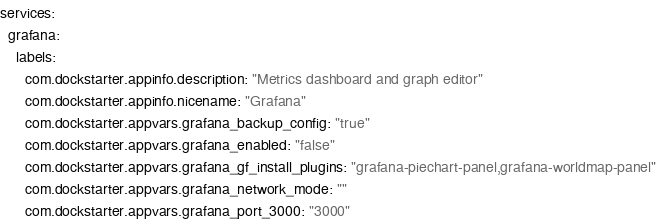Convert code to text. <code><loc_0><loc_0><loc_500><loc_500><_YAML_>services:
  grafana:
    labels:
      com.dockstarter.appinfo.description: "Metrics dashboard and graph editor"
      com.dockstarter.appinfo.nicename: "Grafana"
      com.dockstarter.appvars.grafana_backup_config: "true"
      com.dockstarter.appvars.grafana_enabled: "false"
      com.dockstarter.appvars.grafana_gf_install_plugins: "grafana-piechart-panel,grafana-worldmap-panel"
      com.dockstarter.appvars.grafana_network_mode: ""
      com.dockstarter.appvars.grafana_port_3000: "3000"
</code> 